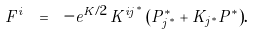<formula> <loc_0><loc_0><loc_500><loc_500>F ^ { i } \ = \ - e ^ { K / 2 } \, K ^ { i j ^ { * } } \, ( P ^ { * } _ { j ^ { * } } + K _ { j ^ { * } } P ^ { * } ) .</formula> 